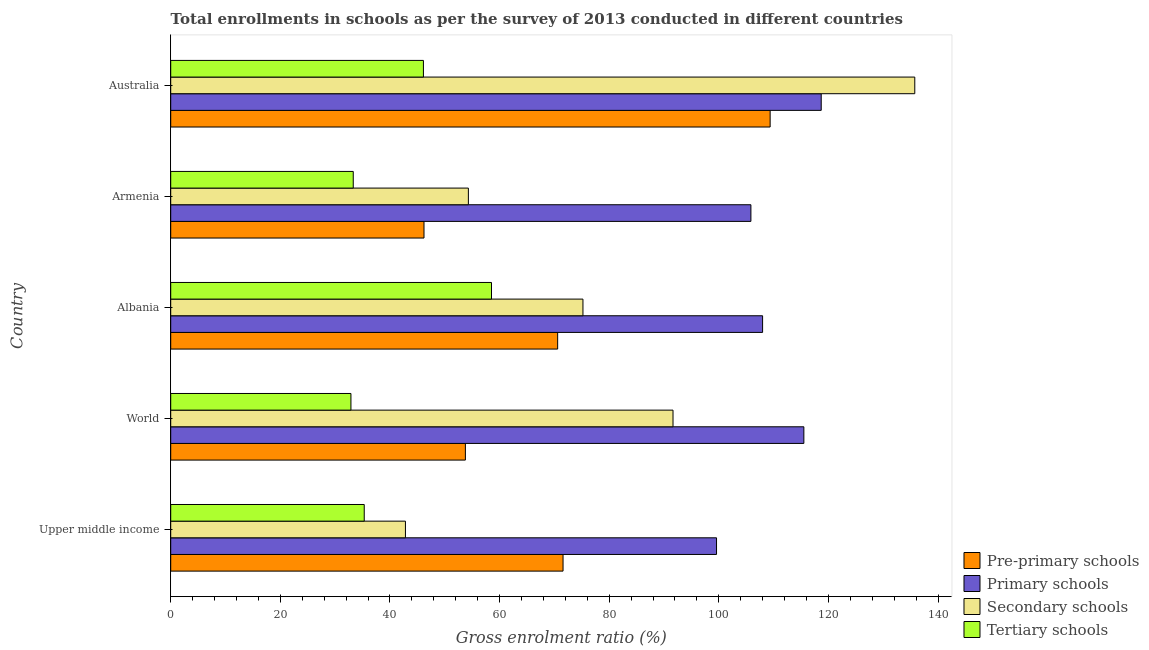How many groups of bars are there?
Keep it short and to the point. 5. Are the number of bars on each tick of the Y-axis equal?
Provide a succinct answer. Yes. How many bars are there on the 5th tick from the bottom?
Ensure brevity in your answer.  4. What is the label of the 2nd group of bars from the top?
Give a very brief answer. Armenia. What is the gross enrolment ratio in tertiary schools in World?
Keep it short and to the point. 32.88. Across all countries, what is the maximum gross enrolment ratio in tertiary schools?
Your answer should be very brief. 58.53. Across all countries, what is the minimum gross enrolment ratio in primary schools?
Ensure brevity in your answer.  99.59. In which country was the gross enrolment ratio in pre-primary schools minimum?
Offer a very short reply. Armenia. What is the total gross enrolment ratio in primary schools in the graph?
Make the answer very short. 547.65. What is the difference between the gross enrolment ratio in primary schools in Albania and that in Armenia?
Keep it short and to the point. 2.13. What is the difference between the gross enrolment ratio in primary schools in Australia and the gross enrolment ratio in pre-primary schools in Upper middle income?
Offer a very short reply. 47.11. What is the average gross enrolment ratio in tertiary schools per country?
Give a very brief answer. 41.23. What is the difference between the gross enrolment ratio in tertiary schools and gross enrolment ratio in secondary schools in Albania?
Keep it short and to the point. -16.68. In how many countries, is the gross enrolment ratio in tertiary schools greater than 24 %?
Ensure brevity in your answer.  5. What is the ratio of the gross enrolment ratio in tertiary schools in Armenia to that in Upper middle income?
Provide a succinct answer. 0.94. Is the difference between the gross enrolment ratio in secondary schools in Albania and Upper middle income greater than the difference between the gross enrolment ratio in tertiary schools in Albania and Upper middle income?
Your response must be concise. Yes. What is the difference between the highest and the second highest gross enrolment ratio in secondary schools?
Provide a short and direct response. 44.11. In how many countries, is the gross enrolment ratio in pre-primary schools greater than the average gross enrolment ratio in pre-primary schools taken over all countries?
Provide a short and direct response. 3. Is it the case that in every country, the sum of the gross enrolment ratio in primary schools and gross enrolment ratio in secondary schools is greater than the sum of gross enrolment ratio in tertiary schools and gross enrolment ratio in pre-primary schools?
Your answer should be very brief. Yes. What does the 4th bar from the top in Upper middle income represents?
Your response must be concise. Pre-primary schools. What does the 2nd bar from the bottom in Australia represents?
Your response must be concise. Primary schools. How many countries are there in the graph?
Your answer should be compact. 5. What is the difference between two consecutive major ticks on the X-axis?
Your response must be concise. 20. What is the title of the graph?
Offer a terse response. Total enrollments in schools as per the survey of 2013 conducted in different countries. What is the label or title of the X-axis?
Your answer should be very brief. Gross enrolment ratio (%). What is the Gross enrolment ratio (%) of Pre-primary schools in Upper middle income?
Make the answer very short. 71.58. What is the Gross enrolment ratio (%) in Primary schools in Upper middle income?
Your answer should be compact. 99.59. What is the Gross enrolment ratio (%) of Secondary schools in Upper middle income?
Your response must be concise. 42.83. What is the Gross enrolment ratio (%) of Tertiary schools in Upper middle income?
Your response must be concise. 35.31. What is the Gross enrolment ratio (%) of Pre-primary schools in World?
Your answer should be compact. 53.77. What is the Gross enrolment ratio (%) of Primary schools in World?
Offer a very short reply. 115.52. What is the Gross enrolment ratio (%) in Secondary schools in World?
Give a very brief answer. 91.65. What is the Gross enrolment ratio (%) of Tertiary schools in World?
Give a very brief answer. 32.88. What is the Gross enrolment ratio (%) of Pre-primary schools in Albania?
Your response must be concise. 70.6. What is the Gross enrolment ratio (%) in Primary schools in Albania?
Offer a very short reply. 107.99. What is the Gross enrolment ratio (%) of Secondary schools in Albania?
Your answer should be very brief. 75.21. What is the Gross enrolment ratio (%) of Tertiary schools in Albania?
Offer a terse response. 58.53. What is the Gross enrolment ratio (%) in Pre-primary schools in Armenia?
Your response must be concise. 46.21. What is the Gross enrolment ratio (%) of Primary schools in Armenia?
Offer a very short reply. 105.86. What is the Gross enrolment ratio (%) in Secondary schools in Armenia?
Your answer should be compact. 54.31. What is the Gross enrolment ratio (%) in Tertiary schools in Armenia?
Give a very brief answer. 33.3. What is the Gross enrolment ratio (%) in Pre-primary schools in Australia?
Your response must be concise. 109.37. What is the Gross enrolment ratio (%) in Primary schools in Australia?
Offer a very short reply. 118.69. What is the Gross enrolment ratio (%) of Secondary schools in Australia?
Offer a terse response. 135.76. What is the Gross enrolment ratio (%) of Tertiary schools in Australia?
Offer a very short reply. 46.11. Across all countries, what is the maximum Gross enrolment ratio (%) in Pre-primary schools?
Provide a short and direct response. 109.37. Across all countries, what is the maximum Gross enrolment ratio (%) of Primary schools?
Ensure brevity in your answer.  118.69. Across all countries, what is the maximum Gross enrolment ratio (%) in Secondary schools?
Give a very brief answer. 135.76. Across all countries, what is the maximum Gross enrolment ratio (%) in Tertiary schools?
Keep it short and to the point. 58.53. Across all countries, what is the minimum Gross enrolment ratio (%) of Pre-primary schools?
Keep it short and to the point. 46.21. Across all countries, what is the minimum Gross enrolment ratio (%) of Primary schools?
Keep it short and to the point. 99.59. Across all countries, what is the minimum Gross enrolment ratio (%) in Secondary schools?
Provide a succinct answer. 42.83. Across all countries, what is the minimum Gross enrolment ratio (%) of Tertiary schools?
Provide a succinct answer. 32.88. What is the total Gross enrolment ratio (%) in Pre-primary schools in the graph?
Your answer should be compact. 351.53. What is the total Gross enrolment ratio (%) in Primary schools in the graph?
Your answer should be very brief. 547.65. What is the total Gross enrolment ratio (%) in Secondary schools in the graph?
Give a very brief answer. 399.76. What is the total Gross enrolment ratio (%) in Tertiary schools in the graph?
Give a very brief answer. 206.14. What is the difference between the Gross enrolment ratio (%) of Pre-primary schools in Upper middle income and that in World?
Provide a succinct answer. 17.82. What is the difference between the Gross enrolment ratio (%) of Primary schools in Upper middle income and that in World?
Your response must be concise. -15.94. What is the difference between the Gross enrolment ratio (%) in Secondary schools in Upper middle income and that in World?
Your answer should be very brief. -48.82. What is the difference between the Gross enrolment ratio (%) in Tertiary schools in Upper middle income and that in World?
Keep it short and to the point. 2.43. What is the difference between the Gross enrolment ratio (%) of Pre-primary schools in Upper middle income and that in Albania?
Give a very brief answer. 0.98. What is the difference between the Gross enrolment ratio (%) of Primary schools in Upper middle income and that in Albania?
Keep it short and to the point. -8.41. What is the difference between the Gross enrolment ratio (%) of Secondary schools in Upper middle income and that in Albania?
Give a very brief answer. -32.39. What is the difference between the Gross enrolment ratio (%) in Tertiary schools in Upper middle income and that in Albania?
Offer a very short reply. -23.22. What is the difference between the Gross enrolment ratio (%) in Pre-primary schools in Upper middle income and that in Armenia?
Make the answer very short. 25.37. What is the difference between the Gross enrolment ratio (%) of Primary schools in Upper middle income and that in Armenia?
Keep it short and to the point. -6.27. What is the difference between the Gross enrolment ratio (%) in Secondary schools in Upper middle income and that in Armenia?
Ensure brevity in your answer.  -11.48. What is the difference between the Gross enrolment ratio (%) of Tertiary schools in Upper middle income and that in Armenia?
Keep it short and to the point. 2. What is the difference between the Gross enrolment ratio (%) in Pre-primary schools in Upper middle income and that in Australia?
Your response must be concise. -37.78. What is the difference between the Gross enrolment ratio (%) of Primary schools in Upper middle income and that in Australia?
Your response must be concise. -19.1. What is the difference between the Gross enrolment ratio (%) in Secondary schools in Upper middle income and that in Australia?
Offer a very short reply. -92.93. What is the difference between the Gross enrolment ratio (%) in Tertiary schools in Upper middle income and that in Australia?
Give a very brief answer. -10.8. What is the difference between the Gross enrolment ratio (%) of Pre-primary schools in World and that in Albania?
Provide a succinct answer. -16.83. What is the difference between the Gross enrolment ratio (%) in Primary schools in World and that in Albania?
Offer a terse response. 7.53. What is the difference between the Gross enrolment ratio (%) of Secondary schools in World and that in Albania?
Make the answer very short. 16.43. What is the difference between the Gross enrolment ratio (%) in Tertiary schools in World and that in Albania?
Your answer should be compact. -25.65. What is the difference between the Gross enrolment ratio (%) of Pre-primary schools in World and that in Armenia?
Offer a very short reply. 7.55. What is the difference between the Gross enrolment ratio (%) of Primary schools in World and that in Armenia?
Give a very brief answer. 9.66. What is the difference between the Gross enrolment ratio (%) in Secondary schools in World and that in Armenia?
Offer a very short reply. 37.34. What is the difference between the Gross enrolment ratio (%) of Tertiary schools in World and that in Armenia?
Offer a terse response. -0.42. What is the difference between the Gross enrolment ratio (%) of Pre-primary schools in World and that in Australia?
Offer a terse response. -55.6. What is the difference between the Gross enrolment ratio (%) in Primary schools in World and that in Australia?
Give a very brief answer. -3.17. What is the difference between the Gross enrolment ratio (%) of Secondary schools in World and that in Australia?
Provide a short and direct response. -44.11. What is the difference between the Gross enrolment ratio (%) of Tertiary schools in World and that in Australia?
Your response must be concise. -13.23. What is the difference between the Gross enrolment ratio (%) in Pre-primary schools in Albania and that in Armenia?
Give a very brief answer. 24.39. What is the difference between the Gross enrolment ratio (%) of Primary schools in Albania and that in Armenia?
Keep it short and to the point. 2.13. What is the difference between the Gross enrolment ratio (%) of Secondary schools in Albania and that in Armenia?
Provide a succinct answer. 20.9. What is the difference between the Gross enrolment ratio (%) of Tertiary schools in Albania and that in Armenia?
Provide a short and direct response. 25.23. What is the difference between the Gross enrolment ratio (%) in Pre-primary schools in Albania and that in Australia?
Give a very brief answer. -38.77. What is the difference between the Gross enrolment ratio (%) of Primary schools in Albania and that in Australia?
Give a very brief answer. -10.7. What is the difference between the Gross enrolment ratio (%) of Secondary schools in Albania and that in Australia?
Give a very brief answer. -60.54. What is the difference between the Gross enrolment ratio (%) in Tertiary schools in Albania and that in Australia?
Provide a succinct answer. 12.42. What is the difference between the Gross enrolment ratio (%) in Pre-primary schools in Armenia and that in Australia?
Keep it short and to the point. -63.15. What is the difference between the Gross enrolment ratio (%) of Primary schools in Armenia and that in Australia?
Ensure brevity in your answer.  -12.83. What is the difference between the Gross enrolment ratio (%) in Secondary schools in Armenia and that in Australia?
Your response must be concise. -81.45. What is the difference between the Gross enrolment ratio (%) of Tertiary schools in Armenia and that in Australia?
Make the answer very short. -12.8. What is the difference between the Gross enrolment ratio (%) in Pre-primary schools in Upper middle income and the Gross enrolment ratio (%) in Primary schools in World?
Your answer should be compact. -43.94. What is the difference between the Gross enrolment ratio (%) of Pre-primary schools in Upper middle income and the Gross enrolment ratio (%) of Secondary schools in World?
Your answer should be very brief. -20.06. What is the difference between the Gross enrolment ratio (%) in Pre-primary schools in Upper middle income and the Gross enrolment ratio (%) in Tertiary schools in World?
Make the answer very short. 38.7. What is the difference between the Gross enrolment ratio (%) in Primary schools in Upper middle income and the Gross enrolment ratio (%) in Secondary schools in World?
Offer a very short reply. 7.94. What is the difference between the Gross enrolment ratio (%) in Primary schools in Upper middle income and the Gross enrolment ratio (%) in Tertiary schools in World?
Your answer should be very brief. 66.7. What is the difference between the Gross enrolment ratio (%) in Secondary schools in Upper middle income and the Gross enrolment ratio (%) in Tertiary schools in World?
Your response must be concise. 9.94. What is the difference between the Gross enrolment ratio (%) in Pre-primary schools in Upper middle income and the Gross enrolment ratio (%) in Primary schools in Albania?
Give a very brief answer. -36.41. What is the difference between the Gross enrolment ratio (%) of Pre-primary schools in Upper middle income and the Gross enrolment ratio (%) of Secondary schools in Albania?
Your answer should be compact. -3.63. What is the difference between the Gross enrolment ratio (%) in Pre-primary schools in Upper middle income and the Gross enrolment ratio (%) in Tertiary schools in Albania?
Ensure brevity in your answer.  13.05. What is the difference between the Gross enrolment ratio (%) in Primary schools in Upper middle income and the Gross enrolment ratio (%) in Secondary schools in Albania?
Provide a short and direct response. 24.37. What is the difference between the Gross enrolment ratio (%) in Primary schools in Upper middle income and the Gross enrolment ratio (%) in Tertiary schools in Albania?
Your answer should be very brief. 41.06. What is the difference between the Gross enrolment ratio (%) of Secondary schools in Upper middle income and the Gross enrolment ratio (%) of Tertiary schools in Albania?
Give a very brief answer. -15.7. What is the difference between the Gross enrolment ratio (%) of Pre-primary schools in Upper middle income and the Gross enrolment ratio (%) of Primary schools in Armenia?
Make the answer very short. -34.28. What is the difference between the Gross enrolment ratio (%) of Pre-primary schools in Upper middle income and the Gross enrolment ratio (%) of Secondary schools in Armenia?
Your response must be concise. 17.27. What is the difference between the Gross enrolment ratio (%) in Pre-primary schools in Upper middle income and the Gross enrolment ratio (%) in Tertiary schools in Armenia?
Your answer should be compact. 38.28. What is the difference between the Gross enrolment ratio (%) of Primary schools in Upper middle income and the Gross enrolment ratio (%) of Secondary schools in Armenia?
Ensure brevity in your answer.  45.28. What is the difference between the Gross enrolment ratio (%) in Primary schools in Upper middle income and the Gross enrolment ratio (%) in Tertiary schools in Armenia?
Your response must be concise. 66.28. What is the difference between the Gross enrolment ratio (%) in Secondary schools in Upper middle income and the Gross enrolment ratio (%) in Tertiary schools in Armenia?
Offer a terse response. 9.52. What is the difference between the Gross enrolment ratio (%) of Pre-primary schools in Upper middle income and the Gross enrolment ratio (%) of Primary schools in Australia?
Offer a terse response. -47.11. What is the difference between the Gross enrolment ratio (%) of Pre-primary schools in Upper middle income and the Gross enrolment ratio (%) of Secondary schools in Australia?
Keep it short and to the point. -64.17. What is the difference between the Gross enrolment ratio (%) of Pre-primary schools in Upper middle income and the Gross enrolment ratio (%) of Tertiary schools in Australia?
Your answer should be compact. 25.47. What is the difference between the Gross enrolment ratio (%) in Primary schools in Upper middle income and the Gross enrolment ratio (%) in Secondary schools in Australia?
Offer a terse response. -36.17. What is the difference between the Gross enrolment ratio (%) of Primary schools in Upper middle income and the Gross enrolment ratio (%) of Tertiary schools in Australia?
Provide a succinct answer. 53.48. What is the difference between the Gross enrolment ratio (%) of Secondary schools in Upper middle income and the Gross enrolment ratio (%) of Tertiary schools in Australia?
Give a very brief answer. -3.28. What is the difference between the Gross enrolment ratio (%) of Pre-primary schools in World and the Gross enrolment ratio (%) of Primary schools in Albania?
Give a very brief answer. -54.23. What is the difference between the Gross enrolment ratio (%) of Pre-primary schools in World and the Gross enrolment ratio (%) of Secondary schools in Albania?
Your answer should be compact. -21.45. What is the difference between the Gross enrolment ratio (%) in Pre-primary schools in World and the Gross enrolment ratio (%) in Tertiary schools in Albania?
Offer a very short reply. -4.76. What is the difference between the Gross enrolment ratio (%) in Primary schools in World and the Gross enrolment ratio (%) in Secondary schools in Albania?
Keep it short and to the point. 40.31. What is the difference between the Gross enrolment ratio (%) in Primary schools in World and the Gross enrolment ratio (%) in Tertiary schools in Albania?
Ensure brevity in your answer.  56.99. What is the difference between the Gross enrolment ratio (%) of Secondary schools in World and the Gross enrolment ratio (%) of Tertiary schools in Albania?
Your answer should be compact. 33.12. What is the difference between the Gross enrolment ratio (%) in Pre-primary schools in World and the Gross enrolment ratio (%) in Primary schools in Armenia?
Your response must be concise. -52.09. What is the difference between the Gross enrolment ratio (%) of Pre-primary schools in World and the Gross enrolment ratio (%) of Secondary schools in Armenia?
Give a very brief answer. -0.55. What is the difference between the Gross enrolment ratio (%) of Pre-primary schools in World and the Gross enrolment ratio (%) of Tertiary schools in Armenia?
Provide a succinct answer. 20.46. What is the difference between the Gross enrolment ratio (%) in Primary schools in World and the Gross enrolment ratio (%) in Secondary schools in Armenia?
Give a very brief answer. 61.21. What is the difference between the Gross enrolment ratio (%) of Primary schools in World and the Gross enrolment ratio (%) of Tertiary schools in Armenia?
Your answer should be compact. 82.22. What is the difference between the Gross enrolment ratio (%) of Secondary schools in World and the Gross enrolment ratio (%) of Tertiary schools in Armenia?
Offer a terse response. 58.34. What is the difference between the Gross enrolment ratio (%) in Pre-primary schools in World and the Gross enrolment ratio (%) in Primary schools in Australia?
Provide a short and direct response. -64.92. What is the difference between the Gross enrolment ratio (%) in Pre-primary schools in World and the Gross enrolment ratio (%) in Secondary schools in Australia?
Keep it short and to the point. -81.99. What is the difference between the Gross enrolment ratio (%) of Pre-primary schools in World and the Gross enrolment ratio (%) of Tertiary schools in Australia?
Keep it short and to the point. 7.66. What is the difference between the Gross enrolment ratio (%) in Primary schools in World and the Gross enrolment ratio (%) in Secondary schools in Australia?
Give a very brief answer. -20.24. What is the difference between the Gross enrolment ratio (%) in Primary schools in World and the Gross enrolment ratio (%) in Tertiary schools in Australia?
Your response must be concise. 69.41. What is the difference between the Gross enrolment ratio (%) of Secondary schools in World and the Gross enrolment ratio (%) of Tertiary schools in Australia?
Your answer should be very brief. 45.54. What is the difference between the Gross enrolment ratio (%) of Pre-primary schools in Albania and the Gross enrolment ratio (%) of Primary schools in Armenia?
Your answer should be compact. -35.26. What is the difference between the Gross enrolment ratio (%) in Pre-primary schools in Albania and the Gross enrolment ratio (%) in Secondary schools in Armenia?
Ensure brevity in your answer.  16.29. What is the difference between the Gross enrolment ratio (%) in Pre-primary schools in Albania and the Gross enrolment ratio (%) in Tertiary schools in Armenia?
Offer a very short reply. 37.29. What is the difference between the Gross enrolment ratio (%) in Primary schools in Albania and the Gross enrolment ratio (%) in Secondary schools in Armenia?
Offer a terse response. 53.68. What is the difference between the Gross enrolment ratio (%) in Primary schools in Albania and the Gross enrolment ratio (%) in Tertiary schools in Armenia?
Give a very brief answer. 74.69. What is the difference between the Gross enrolment ratio (%) of Secondary schools in Albania and the Gross enrolment ratio (%) of Tertiary schools in Armenia?
Offer a terse response. 41.91. What is the difference between the Gross enrolment ratio (%) in Pre-primary schools in Albania and the Gross enrolment ratio (%) in Primary schools in Australia?
Offer a very short reply. -48.09. What is the difference between the Gross enrolment ratio (%) in Pre-primary schools in Albania and the Gross enrolment ratio (%) in Secondary schools in Australia?
Your answer should be compact. -65.16. What is the difference between the Gross enrolment ratio (%) in Pre-primary schools in Albania and the Gross enrolment ratio (%) in Tertiary schools in Australia?
Ensure brevity in your answer.  24.49. What is the difference between the Gross enrolment ratio (%) of Primary schools in Albania and the Gross enrolment ratio (%) of Secondary schools in Australia?
Offer a terse response. -27.77. What is the difference between the Gross enrolment ratio (%) of Primary schools in Albania and the Gross enrolment ratio (%) of Tertiary schools in Australia?
Provide a succinct answer. 61.88. What is the difference between the Gross enrolment ratio (%) in Secondary schools in Albania and the Gross enrolment ratio (%) in Tertiary schools in Australia?
Your answer should be very brief. 29.11. What is the difference between the Gross enrolment ratio (%) in Pre-primary schools in Armenia and the Gross enrolment ratio (%) in Primary schools in Australia?
Offer a terse response. -72.48. What is the difference between the Gross enrolment ratio (%) in Pre-primary schools in Armenia and the Gross enrolment ratio (%) in Secondary schools in Australia?
Make the answer very short. -89.54. What is the difference between the Gross enrolment ratio (%) of Pre-primary schools in Armenia and the Gross enrolment ratio (%) of Tertiary schools in Australia?
Offer a very short reply. 0.1. What is the difference between the Gross enrolment ratio (%) of Primary schools in Armenia and the Gross enrolment ratio (%) of Secondary schools in Australia?
Your response must be concise. -29.9. What is the difference between the Gross enrolment ratio (%) in Primary schools in Armenia and the Gross enrolment ratio (%) in Tertiary schools in Australia?
Your response must be concise. 59.75. What is the difference between the Gross enrolment ratio (%) of Secondary schools in Armenia and the Gross enrolment ratio (%) of Tertiary schools in Australia?
Offer a very short reply. 8.2. What is the average Gross enrolment ratio (%) of Pre-primary schools per country?
Offer a terse response. 70.31. What is the average Gross enrolment ratio (%) of Primary schools per country?
Your response must be concise. 109.53. What is the average Gross enrolment ratio (%) in Secondary schools per country?
Make the answer very short. 79.95. What is the average Gross enrolment ratio (%) in Tertiary schools per country?
Make the answer very short. 41.23. What is the difference between the Gross enrolment ratio (%) in Pre-primary schools and Gross enrolment ratio (%) in Primary schools in Upper middle income?
Ensure brevity in your answer.  -28. What is the difference between the Gross enrolment ratio (%) of Pre-primary schools and Gross enrolment ratio (%) of Secondary schools in Upper middle income?
Offer a terse response. 28.76. What is the difference between the Gross enrolment ratio (%) in Pre-primary schools and Gross enrolment ratio (%) in Tertiary schools in Upper middle income?
Your answer should be very brief. 36.27. What is the difference between the Gross enrolment ratio (%) of Primary schools and Gross enrolment ratio (%) of Secondary schools in Upper middle income?
Ensure brevity in your answer.  56.76. What is the difference between the Gross enrolment ratio (%) of Primary schools and Gross enrolment ratio (%) of Tertiary schools in Upper middle income?
Provide a succinct answer. 64.28. What is the difference between the Gross enrolment ratio (%) of Secondary schools and Gross enrolment ratio (%) of Tertiary schools in Upper middle income?
Offer a very short reply. 7.52. What is the difference between the Gross enrolment ratio (%) of Pre-primary schools and Gross enrolment ratio (%) of Primary schools in World?
Provide a short and direct response. -61.76. What is the difference between the Gross enrolment ratio (%) of Pre-primary schools and Gross enrolment ratio (%) of Secondary schools in World?
Offer a terse response. -37.88. What is the difference between the Gross enrolment ratio (%) in Pre-primary schools and Gross enrolment ratio (%) in Tertiary schools in World?
Provide a short and direct response. 20.88. What is the difference between the Gross enrolment ratio (%) of Primary schools and Gross enrolment ratio (%) of Secondary schools in World?
Make the answer very short. 23.87. What is the difference between the Gross enrolment ratio (%) in Primary schools and Gross enrolment ratio (%) in Tertiary schools in World?
Offer a terse response. 82.64. What is the difference between the Gross enrolment ratio (%) in Secondary schools and Gross enrolment ratio (%) in Tertiary schools in World?
Offer a terse response. 58.76. What is the difference between the Gross enrolment ratio (%) in Pre-primary schools and Gross enrolment ratio (%) in Primary schools in Albania?
Keep it short and to the point. -37.39. What is the difference between the Gross enrolment ratio (%) of Pre-primary schools and Gross enrolment ratio (%) of Secondary schools in Albania?
Make the answer very short. -4.61. What is the difference between the Gross enrolment ratio (%) of Pre-primary schools and Gross enrolment ratio (%) of Tertiary schools in Albania?
Provide a succinct answer. 12.07. What is the difference between the Gross enrolment ratio (%) of Primary schools and Gross enrolment ratio (%) of Secondary schools in Albania?
Your response must be concise. 32.78. What is the difference between the Gross enrolment ratio (%) in Primary schools and Gross enrolment ratio (%) in Tertiary schools in Albania?
Provide a short and direct response. 49.46. What is the difference between the Gross enrolment ratio (%) in Secondary schools and Gross enrolment ratio (%) in Tertiary schools in Albania?
Your answer should be very brief. 16.68. What is the difference between the Gross enrolment ratio (%) of Pre-primary schools and Gross enrolment ratio (%) of Primary schools in Armenia?
Provide a succinct answer. -59.65. What is the difference between the Gross enrolment ratio (%) of Pre-primary schools and Gross enrolment ratio (%) of Secondary schools in Armenia?
Provide a short and direct response. -8.1. What is the difference between the Gross enrolment ratio (%) in Pre-primary schools and Gross enrolment ratio (%) in Tertiary schools in Armenia?
Provide a short and direct response. 12.91. What is the difference between the Gross enrolment ratio (%) in Primary schools and Gross enrolment ratio (%) in Secondary schools in Armenia?
Provide a short and direct response. 51.55. What is the difference between the Gross enrolment ratio (%) in Primary schools and Gross enrolment ratio (%) in Tertiary schools in Armenia?
Provide a succinct answer. 72.56. What is the difference between the Gross enrolment ratio (%) of Secondary schools and Gross enrolment ratio (%) of Tertiary schools in Armenia?
Your answer should be very brief. 21.01. What is the difference between the Gross enrolment ratio (%) of Pre-primary schools and Gross enrolment ratio (%) of Primary schools in Australia?
Offer a terse response. -9.32. What is the difference between the Gross enrolment ratio (%) of Pre-primary schools and Gross enrolment ratio (%) of Secondary schools in Australia?
Your response must be concise. -26.39. What is the difference between the Gross enrolment ratio (%) in Pre-primary schools and Gross enrolment ratio (%) in Tertiary schools in Australia?
Keep it short and to the point. 63.26. What is the difference between the Gross enrolment ratio (%) of Primary schools and Gross enrolment ratio (%) of Secondary schools in Australia?
Your answer should be very brief. -17.07. What is the difference between the Gross enrolment ratio (%) of Primary schools and Gross enrolment ratio (%) of Tertiary schools in Australia?
Offer a terse response. 72.58. What is the difference between the Gross enrolment ratio (%) in Secondary schools and Gross enrolment ratio (%) in Tertiary schools in Australia?
Make the answer very short. 89.65. What is the ratio of the Gross enrolment ratio (%) in Pre-primary schools in Upper middle income to that in World?
Offer a terse response. 1.33. What is the ratio of the Gross enrolment ratio (%) of Primary schools in Upper middle income to that in World?
Make the answer very short. 0.86. What is the ratio of the Gross enrolment ratio (%) in Secondary schools in Upper middle income to that in World?
Provide a short and direct response. 0.47. What is the ratio of the Gross enrolment ratio (%) in Tertiary schools in Upper middle income to that in World?
Offer a terse response. 1.07. What is the ratio of the Gross enrolment ratio (%) of Pre-primary schools in Upper middle income to that in Albania?
Provide a succinct answer. 1.01. What is the ratio of the Gross enrolment ratio (%) in Primary schools in Upper middle income to that in Albania?
Your answer should be compact. 0.92. What is the ratio of the Gross enrolment ratio (%) in Secondary schools in Upper middle income to that in Albania?
Make the answer very short. 0.57. What is the ratio of the Gross enrolment ratio (%) in Tertiary schools in Upper middle income to that in Albania?
Make the answer very short. 0.6. What is the ratio of the Gross enrolment ratio (%) of Pre-primary schools in Upper middle income to that in Armenia?
Provide a succinct answer. 1.55. What is the ratio of the Gross enrolment ratio (%) of Primary schools in Upper middle income to that in Armenia?
Your response must be concise. 0.94. What is the ratio of the Gross enrolment ratio (%) in Secondary schools in Upper middle income to that in Armenia?
Provide a succinct answer. 0.79. What is the ratio of the Gross enrolment ratio (%) in Tertiary schools in Upper middle income to that in Armenia?
Your answer should be very brief. 1.06. What is the ratio of the Gross enrolment ratio (%) of Pre-primary schools in Upper middle income to that in Australia?
Your answer should be compact. 0.65. What is the ratio of the Gross enrolment ratio (%) in Primary schools in Upper middle income to that in Australia?
Your response must be concise. 0.84. What is the ratio of the Gross enrolment ratio (%) of Secondary schools in Upper middle income to that in Australia?
Your response must be concise. 0.32. What is the ratio of the Gross enrolment ratio (%) of Tertiary schools in Upper middle income to that in Australia?
Offer a terse response. 0.77. What is the ratio of the Gross enrolment ratio (%) in Pre-primary schools in World to that in Albania?
Make the answer very short. 0.76. What is the ratio of the Gross enrolment ratio (%) in Primary schools in World to that in Albania?
Your answer should be very brief. 1.07. What is the ratio of the Gross enrolment ratio (%) in Secondary schools in World to that in Albania?
Your answer should be very brief. 1.22. What is the ratio of the Gross enrolment ratio (%) of Tertiary schools in World to that in Albania?
Make the answer very short. 0.56. What is the ratio of the Gross enrolment ratio (%) in Pre-primary schools in World to that in Armenia?
Offer a terse response. 1.16. What is the ratio of the Gross enrolment ratio (%) in Primary schools in World to that in Armenia?
Your answer should be compact. 1.09. What is the ratio of the Gross enrolment ratio (%) in Secondary schools in World to that in Armenia?
Your response must be concise. 1.69. What is the ratio of the Gross enrolment ratio (%) in Tertiary schools in World to that in Armenia?
Give a very brief answer. 0.99. What is the ratio of the Gross enrolment ratio (%) in Pre-primary schools in World to that in Australia?
Make the answer very short. 0.49. What is the ratio of the Gross enrolment ratio (%) in Primary schools in World to that in Australia?
Keep it short and to the point. 0.97. What is the ratio of the Gross enrolment ratio (%) in Secondary schools in World to that in Australia?
Make the answer very short. 0.68. What is the ratio of the Gross enrolment ratio (%) in Tertiary schools in World to that in Australia?
Your answer should be very brief. 0.71. What is the ratio of the Gross enrolment ratio (%) in Pre-primary schools in Albania to that in Armenia?
Offer a terse response. 1.53. What is the ratio of the Gross enrolment ratio (%) in Primary schools in Albania to that in Armenia?
Your answer should be compact. 1.02. What is the ratio of the Gross enrolment ratio (%) of Secondary schools in Albania to that in Armenia?
Your response must be concise. 1.38. What is the ratio of the Gross enrolment ratio (%) of Tertiary schools in Albania to that in Armenia?
Ensure brevity in your answer.  1.76. What is the ratio of the Gross enrolment ratio (%) of Pre-primary schools in Albania to that in Australia?
Offer a very short reply. 0.65. What is the ratio of the Gross enrolment ratio (%) of Primary schools in Albania to that in Australia?
Your answer should be very brief. 0.91. What is the ratio of the Gross enrolment ratio (%) in Secondary schools in Albania to that in Australia?
Your answer should be very brief. 0.55. What is the ratio of the Gross enrolment ratio (%) of Tertiary schools in Albania to that in Australia?
Your response must be concise. 1.27. What is the ratio of the Gross enrolment ratio (%) in Pre-primary schools in Armenia to that in Australia?
Keep it short and to the point. 0.42. What is the ratio of the Gross enrolment ratio (%) in Primary schools in Armenia to that in Australia?
Make the answer very short. 0.89. What is the ratio of the Gross enrolment ratio (%) in Secondary schools in Armenia to that in Australia?
Your response must be concise. 0.4. What is the ratio of the Gross enrolment ratio (%) of Tertiary schools in Armenia to that in Australia?
Your response must be concise. 0.72. What is the difference between the highest and the second highest Gross enrolment ratio (%) in Pre-primary schools?
Offer a terse response. 37.78. What is the difference between the highest and the second highest Gross enrolment ratio (%) in Primary schools?
Your response must be concise. 3.17. What is the difference between the highest and the second highest Gross enrolment ratio (%) of Secondary schools?
Your answer should be very brief. 44.11. What is the difference between the highest and the second highest Gross enrolment ratio (%) in Tertiary schools?
Offer a very short reply. 12.42. What is the difference between the highest and the lowest Gross enrolment ratio (%) of Pre-primary schools?
Make the answer very short. 63.15. What is the difference between the highest and the lowest Gross enrolment ratio (%) in Primary schools?
Provide a short and direct response. 19.1. What is the difference between the highest and the lowest Gross enrolment ratio (%) of Secondary schools?
Offer a very short reply. 92.93. What is the difference between the highest and the lowest Gross enrolment ratio (%) of Tertiary schools?
Your answer should be compact. 25.65. 